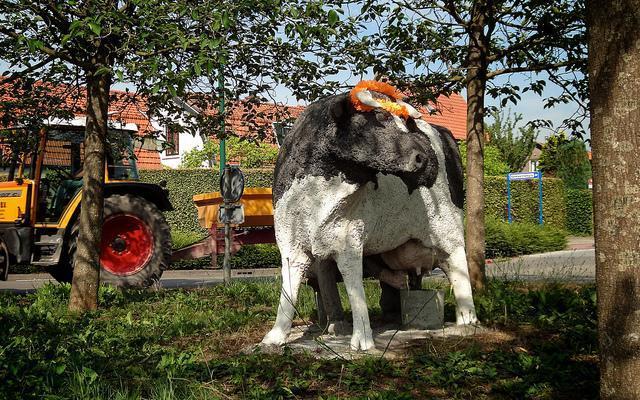How many trucks are there?
Give a very brief answer. 1. 